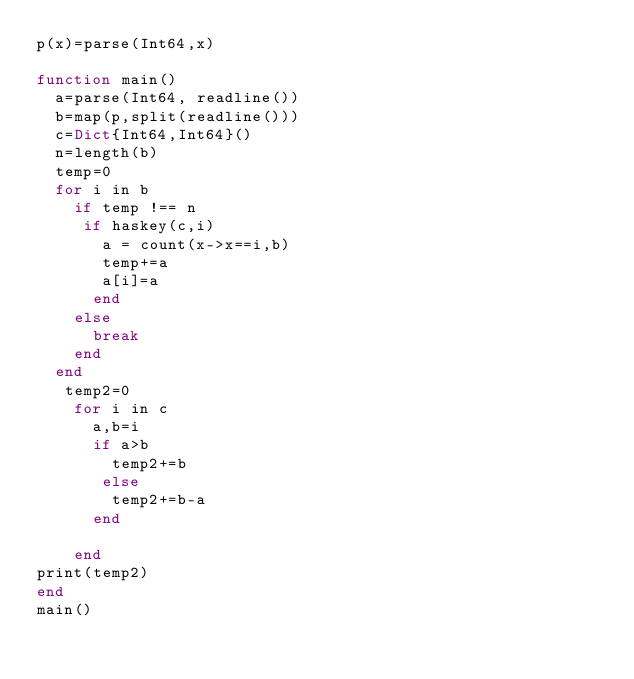Convert code to text. <code><loc_0><loc_0><loc_500><loc_500><_Julia_>p(x)=parse(Int64,x)
    
function main()
  a=parse(Int64, readline())
  b=map(p,split(readline()))
  c=Dict{Int64,Int64}()
  n=length(b)
  temp=0
  for i in b
    if temp !== n
     if haskey(c,i)
       a = count(x->x==i,b)
       temp+=a
       a[i]=a
      end
    else
      break
    end
  end
   temp2=0
    for i in c
      a,b=i
      if a>b
        temp2+=b
       else
        temp2+=b-a
      end
      
    end
print(temp2)  
end
main()

    </code> 